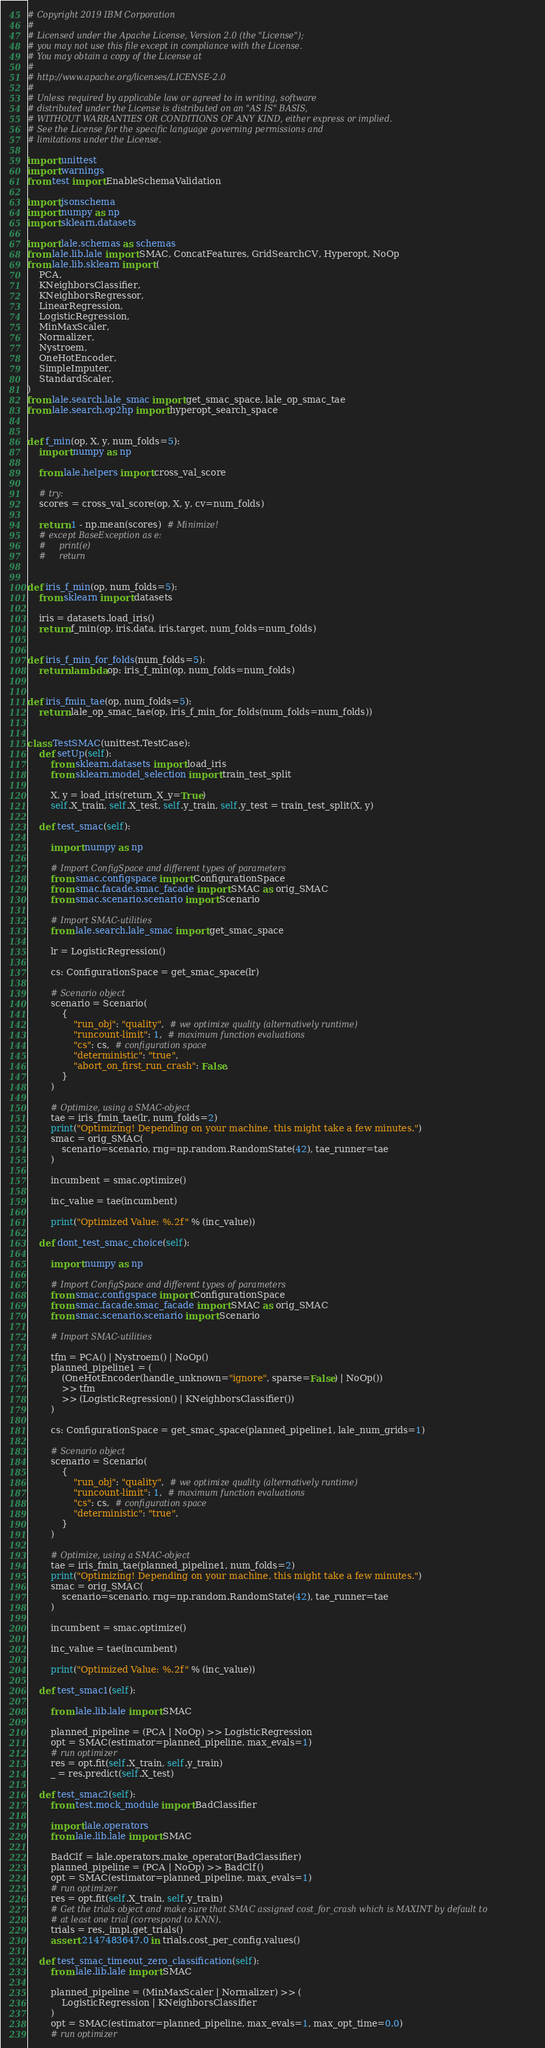<code> <loc_0><loc_0><loc_500><loc_500><_Python_># Copyright 2019 IBM Corporation
#
# Licensed under the Apache License, Version 2.0 (the "License");
# you may not use this file except in compliance with the License.
# You may obtain a copy of the License at
#
# http://www.apache.org/licenses/LICENSE-2.0
#
# Unless required by applicable law or agreed to in writing, software
# distributed under the License is distributed on an "AS IS" BASIS,
# WITHOUT WARRANTIES OR CONDITIONS OF ANY KIND, either express or implied.
# See the License for the specific language governing permissions and
# limitations under the License.

import unittest
import warnings
from test import EnableSchemaValidation

import jsonschema
import numpy as np
import sklearn.datasets

import lale.schemas as schemas
from lale.lib.lale import SMAC, ConcatFeatures, GridSearchCV, Hyperopt, NoOp
from lale.lib.sklearn import (
    PCA,
    KNeighborsClassifier,
    KNeighborsRegressor,
    LinearRegression,
    LogisticRegression,
    MinMaxScaler,
    Normalizer,
    Nystroem,
    OneHotEncoder,
    SimpleImputer,
    StandardScaler,
)
from lale.search.lale_smac import get_smac_space, lale_op_smac_tae
from lale.search.op2hp import hyperopt_search_space


def f_min(op, X, y, num_folds=5):
    import numpy as np

    from lale.helpers import cross_val_score

    # try:
    scores = cross_val_score(op, X, y, cv=num_folds)

    return 1 - np.mean(scores)  # Minimize!
    # except BaseException as e:
    #     print(e)
    #     return


def iris_f_min(op, num_folds=5):
    from sklearn import datasets

    iris = datasets.load_iris()
    return f_min(op, iris.data, iris.target, num_folds=num_folds)


def iris_f_min_for_folds(num_folds=5):
    return lambda op: iris_f_min(op, num_folds=num_folds)


def iris_fmin_tae(op, num_folds=5):
    return lale_op_smac_tae(op, iris_f_min_for_folds(num_folds=num_folds))


class TestSMAC(unittest.TestCase):
    def setUp(self):
        from sklearn.datasets import load_iris
        from sklearn.model_selection import train_test_split

        X, y = load_iris(return_X_y=True)
        self.X_train, self.X_test, self.y_train, self.y_test = train_test_split(X, y)

    def test_smac(self):

        import numpy as np

        # Import ConfigSpace and different types of parameters
        from smac.configspace import ConfigurationSpace
        from smac.facade.smac_facade import SMAC as orig_SMAC
        from smac.scenario.scenario import Scenario

        # Import SMAC-utilities
        from lale.search.lale_smac import get_smac_space

        lr = LogisticRegression()

        cs: ConfigurationSpace = get_smac_space(lr)

        # Scenario object
        scenario = Scenario(
            {
                "run_obj": "quality",  # we optimize quality (alternatively runtime)
                "runcount-limit": 1,  # maximum function evaluations
                "cs": cs,  # configuration space
                "deterministic": "true",
                "abort_on_first_run_crash": False,
            }
        )

        # Optimize, using a SMAC-object
        tae = iris_fmin_tae(lr, num_folds=2)
        print("Optimizing! Depending on your machine, this might take a few minutes.")
        smac = orig_SMAC(
            scenario=scenario, rng=np.random.RandomState(42), tae_runner=tae
        )

        incumbent = smac.optimize()

        inc_value = tae(incumbent)

        print("Optimized Value: %.2f" % (inc_value))

    def dont_test_smac_choice(self):

        import numpy as np

        # Import ConfigSpace and different types of parameters
        from smac.configspace import ConfigurationSpace
        from smac.facade.smac_facade import SMAC as orig_SMAC
        from smac.scenario.scenario import Scenario

        # Import SMAC-utilities

        tfm = PCA() | Nystroem() | NoOp()
        planned_pipeline1 = (
            (OneHotEncoder(handle_unknown="ignore", sparse=False) | NoOp())
            >> tfm
            >> (LogisticRegression() | KNeighborsClassifier())
        )

        cs: ConfigurationSpace = get_smac_space(planned_pipeline1, lale_num_grids=1)

        # Scenario object
        scenario = Scenario(
            {
                "run_obj": "quality",  # we optimize quality (alternatively runtime)
                "runcount-limit": 1,  # maximum function evaluations
                "cs": cs,  # configuration space
                "deterministic": "true",
            }
        )

        # Optimize, using a SMAC-object
        tae = iris_fmin_tae(planned_pipeline1, num_folds=2)
        print("Optimizing! Depending on your machine, this might take a few minutes.")
        smac = orig_SMAC(
            scenario=scenario, rng=np.random.RandomState(42), tae_runner=tae
        )

        incumbent = smac.optimize()

        inc_value = tae(incumbent)

        print("Optimized Value: %.2f" % (inc_value))

    def test_smac1(self):

        from lale.lib.lale import SMAC

        planned_pipeline = (PCA | NoOp) >> LogisticRegression
        opt = SMAC(estimator=planned_pipeline, max_evals=1)
        # run optimizer
        res = opt.fit(self.X_train, self.y_train)
        _ = res.predict(self.X_test)

    def test_smac2(self):
        from test.mock_module import BadClassifier

        import lale.operators
        from lale.lib.lale import SMAC

        BadClf = lale.operators.make_operator(BadClassifier)
        planned_pipeline = (PCA | NoOp) >> BadClf()
        opt = SMAC(estimator=planned_pipeline, max_evals=1)
        # run optimizer
        res = opt.fit(self.X_train, self.y_train)
        # Get the trials object and make sure that SMAC assigned cost_for_crash which is MAXINT by default to
        # at least one trial (correspond to KNN).
        trials = res._impl.get_trials()
        assert 2147483647.0 in trials.cost_per_config.values()

    def test_smac_timeout_zero_classification(self):
        from lale.lib.lale import SMAC

        planned_pipeline = (MinMaxScaler | Normalizer) >> (
            LogisticRegression | KNeighborsClassifier
        )
        opt = SMAC(estimator=planned_pipeline, max_evals=1, max_opt_time=0.0)
        # run optimizer</code> 